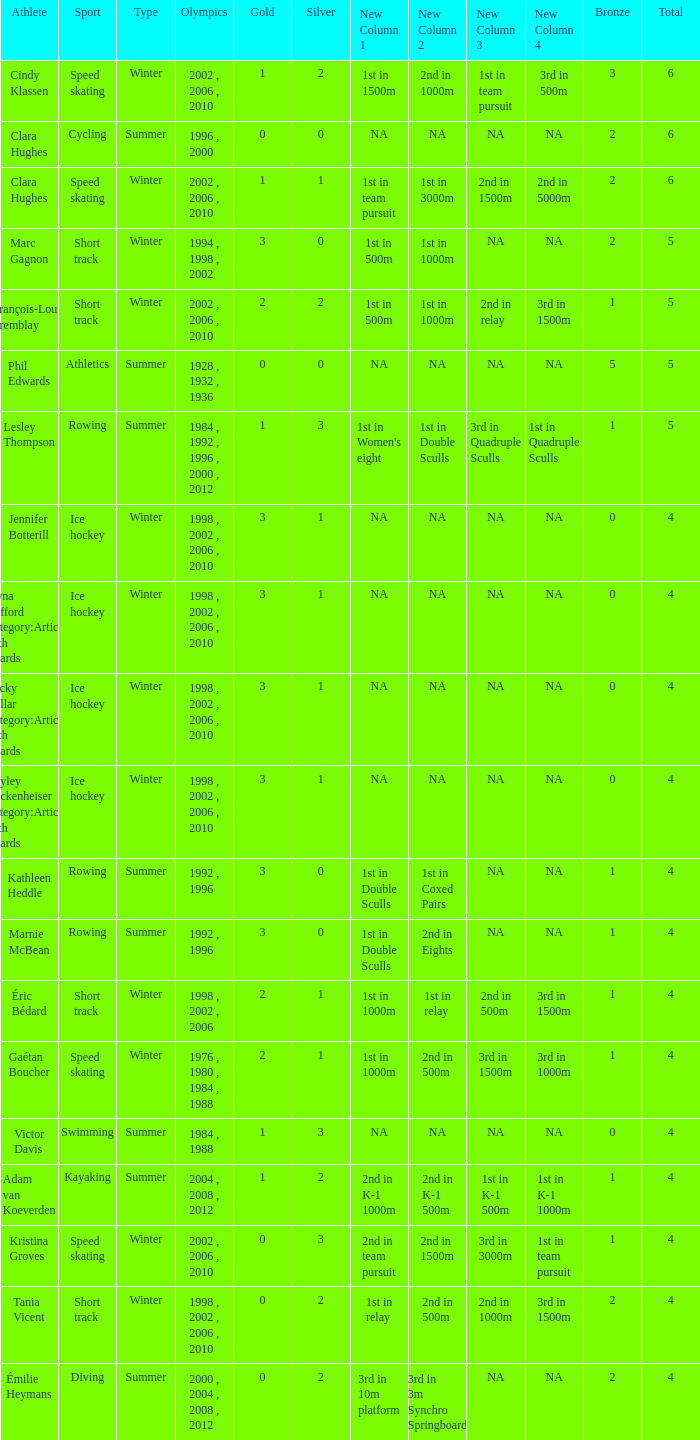What is the lowest number of bronze a short track athlete with 0 gold medals has? 2.0. I'm looking to parse the entire table for insights. Could you assist me with that? {'header': ['Athlete', 'Sport', 'Type', 'Olympics', 'Gold', 'Silver', 'New Column 1', 'New Column 2', 'New Column 3', 'New Column 4', 'Bronze', 'Total'], 'rows': [['Cindy Klassen', 'Speed skating', 'Winter', '2002 , 2006 , 2010', '1', '2', '1st in 1500m', '2nd in 1000m', '1st in team pursuit', '3rd in 500m', '3', '6'], ['Clara Hughes', 'Cycling', 'Summer', '1996 , 2000', '0', '0', 'NA', 'NA', 'NA', 'NA', '2', '6'], ['Clara Hughes', 'Speed skating', 'Winter', '2002 , 2006 , 2010', '1', '1', '1st in team pursuit', '1st in 3000m', '2nd in 1500m', '2nd in 5000m', '2', '6'], ['Marc Gagnon', 'Short track', 'Winter', '1994 , 1998 , 2002', '3', '0', '1st in 500m', '1st in 1000m', 'NA', 'NA', '2', '5'], ['François-Louis Tremblay', 'Short track', 'Winter', '2002 , 2006 , 2010', '2', '2', '1st in 500m', '1st in 1000m', '2nd in relay', '3rd in 1500m', '1', '5'], ['Phil Edwards', 'Athletics', 'Summer', '1928 , 1932 , 1936', '0', '0', 'NA', 'NA', 'NA', 'NA', '5', '5'], ['Lesley Thompson', 'Rowing', 'Summer', '1984 , 1992 , 1996 , 2000 , 2012', '1', '3', "1st in Women's eight", '1st in Double Sculls', '3rd in Quadruple Sculls', '1st in Quadruple Sculls', '1', '5'], ['Jennifer Botterill', 'Ice hockey', 'Winter', '1998 , 2002 , 2006 , 2010', '3', '1', 'NA', 'NA', 'NA', 'NA', '0', '4'], ['Jayna Hefford Category:Articles with hCards', 'Ice hockey', 'Winter', '1998 , 2002 , 2006 , 2010', '3', '1', 'NA', 'NA', 'NA', 'NA', '0', '4'], ['Becky Kellar Category:Articles with hCards', 'Ice hockey', 'Winter', '1998 , 2002 , 2006 , 2010', '3', '1', 'NA', 'NA', 'NA', 'NA', '0', '4'], ['Hayley Wickenheiser Category:Articles with hCards', 'Ice hockey', 'Winter', '1998 , 2002 , 2006 , 2010', '3', '1', 'NA', 'NA', 'NA', 'NA', '0', '4'], ['Kathleen Heddle', 'Rowing', 'Summer', '1992 , 1996', '3', '0', '1st in Double Sculls', '1st in Coxed Pairs', 'NA', 'NA', '1', '4'], ['Marnie McBean', 'Rowing', 'Summer', '1992 , 1996', '3', '0', '1st in Double Sculls', '2nd in Eights', 'NA', 'NA', '1', '4'], ['Éric Bédard', 'Short track', 'Winter', '1998 , 2002 , 2006', '2', '1', '1st in 1000m', '1st in relay', '2nd in 500m', '3rd in 1500m', '1', '4'], ['Gaétan Boucher', 'Speed skating', 'Winter', '1976 , 1980 , 1984 , 1988', '2', '1', '1st in 1000m', '2nd in 500m', '3rd in 1500m', '3rd in 1000m', '1', '4'], ['Victor Davis', 'Swimming', 'Summer', '1984 , 1988', '1', '3', 'NA', 'NA', 'NA', 'NA', '0', '4'], ['Adam van Koeverden', 'Kayaking', 'Summer', '2004 , 2008 , 2012', '1', '2', '2nd in K-1 1000m', '2nd in K-1 500m', '1st in K-1 500m', '1st in K-1 1000m', '1', '4'], ['Kristina Groves', 'Speed skating', 'Winter', '2002 , 2006 , 2010', '0', '3', '2nd in team pursuit', '2nd in 1500m', '3rd in 3000m', '1st in team pursuit', '1', '4'], ['Tania Vicent', 'Short track', 'Winter', '1998 , 2002 , 2006 , 2010', '0', '2', '1st in relay', '2nd in 500m', '2nd in 1000m', '3rd in 1500m', '2', '4'], ['Émilie Heymans', 'Diving', 'Summer', '2000 , 2004 , 2008 , 2012', '0', '2', '3rd in 10m platform', '3rd in 3m Synchro Springboard', 'NA', 'NA', '2', '4']]} 